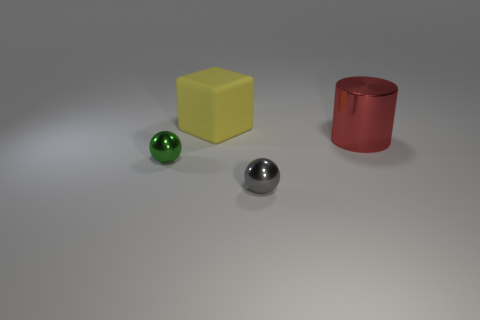Subtract all cylinders. How many objects are left? 3 Subtract all gray metallic cylinders. Subtract all big metallic objects. How many objects are left? 3 Add 1 large objects. How many large objects are left? 3 Add 4 yellow blocks. How many yellow blocks exist? 5 Add 3 gray things. How many objects exist? 7 Subtract 1 gray spheres. How many objects are left? 3 Subtract all yellow spheres. Subtract all gray blocks. How many spheres are left? 2 Subtract all yellow cylinders. How many gray spheres are left? 1 